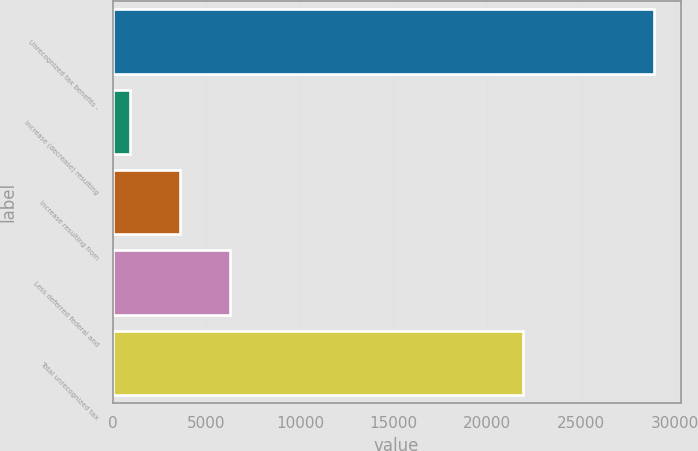Convert chart to OTSL. <chart><loc_0><loc_0><loc_500><loc_500><bar_chart><fcel>Unrecognized tax benefits -<fcel>Increase (decrease) resulting<fcel>Increase resulting from<fcel>Less deferred federal and<fcel>Total unrecognized tax<nl><fcel>28882.3<fcel>923<fcel>3602.3<fcel>6281.6<fcel>21896<nl></chart> 